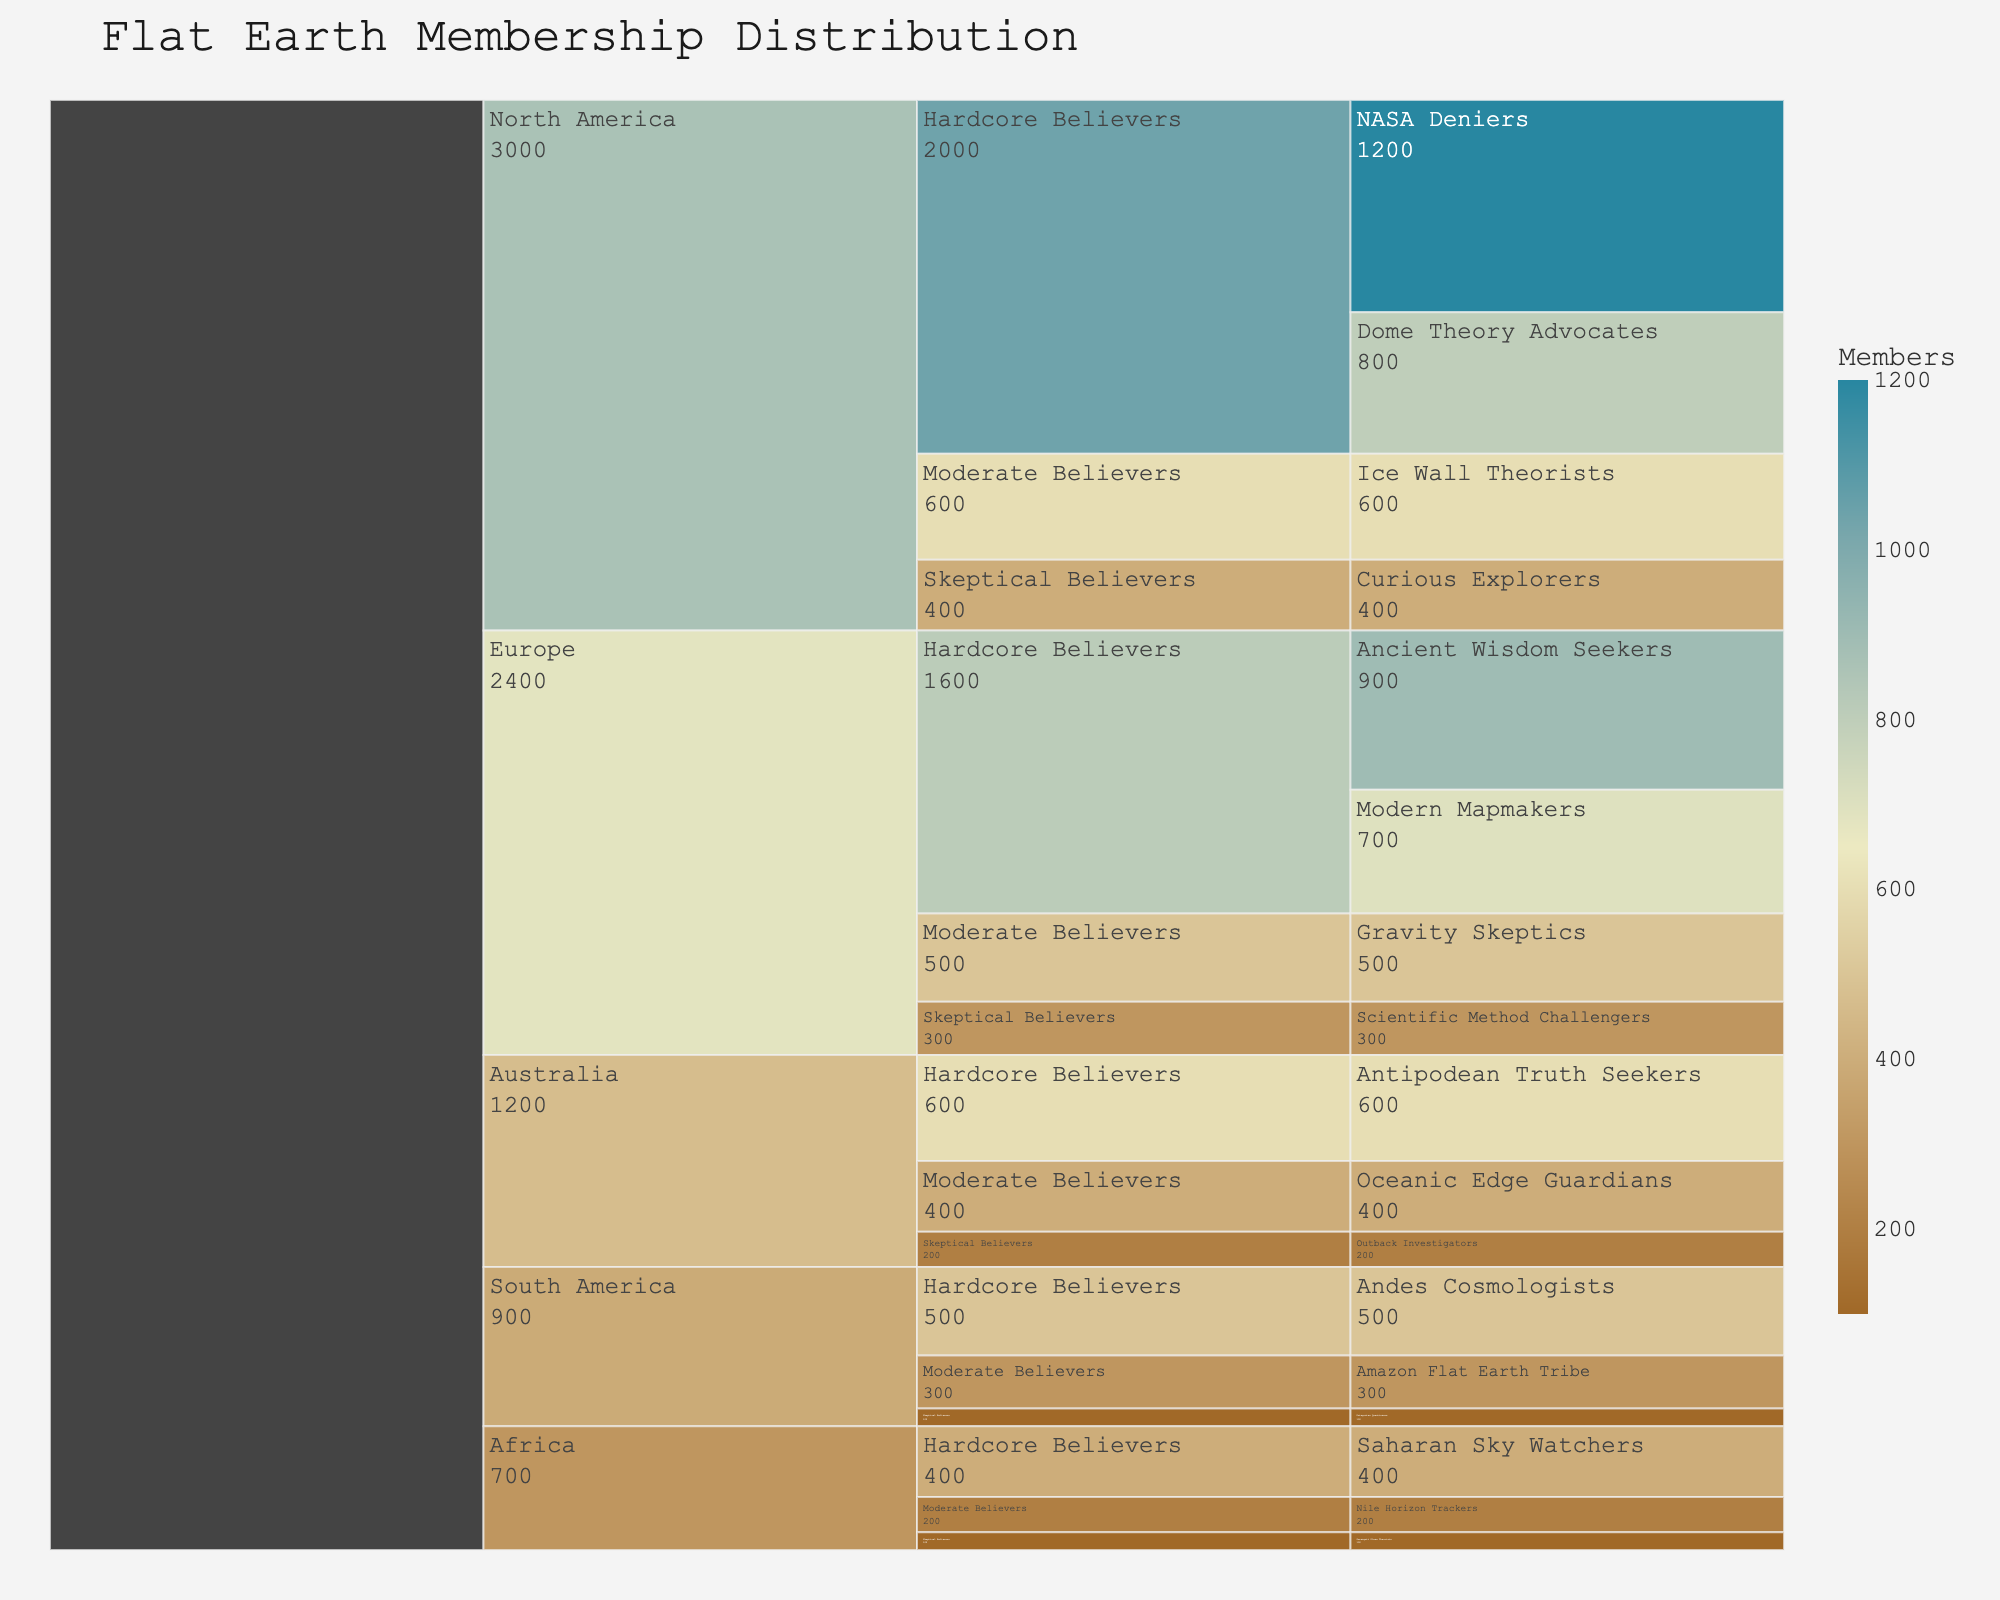What is the title of the figure? The title is usually displayed prominently at the top of the figure. By looking at this part of the figure, we can find the title.
Answer: Flat Earth Membership Distribution Which subgroup in South America has the highest number of members? Look at the South America section in the figure and identify the subgroup with the longest bar or highest value.
Answer: Andes Cosmologists How many total members are there in Australia? Sum the number of members in all subgroups within the Australia section: 600 (Antipodean Truth Seekers) + 400 (Oceanic Edge Guardians) + 200 (Outback Investigators).
Answer: 1200 Which region has the most Hardcore Believers? Compare the number of Hardcore Believers from each region by looking at the figures under the Hardcore Believers category. North America: 1200+800, Europe: 900+700, Australia: 600, South America: 500, Africa: 400. North America has the most.
Answer: North America How many members are categorized as Skeptical Believers in Europe? Sum the members in the Skeptical Believers subgroup within Europe: 300.
Answer: 300 What's the difference in the number of members between the Ice Wall Theorists (North America) and the Patagonian Questioners (South America)? Subtract the number of members of Patagonian Questioners from the Ice Wall Theorists: 600 (Ice Wall Theorists) - 100 (Patagonian Questioners).
Answer: 500 Which region has the smallest number of members in the Skeptical Believers category? Compare the number of Skeptical Believers in each region and find the smallest: North America (400), Europe (300), Australia (200), South America (100), Africa (100). Africa and South America have the same smallest number.
Answer: Africa, South America What is the total number of Hardcore Believers across all regions? Sum the number of Hardcore Believers from all regions: North America: 1200+800, Europe: 900+700, Australia: 600, South America: 500, Africa: 400. The total is (1200+800+900+700+600+500+400).
Answer: 5100 How does the number of Modern Mapmakers in Europe compare to Gravity Skeptics in Europe? Compare the two values in the Europe section. Modern Mapmakers: 700, Gravity Skeptics: 500.
Answer: Modern Mapmakers have more members than Gravity Skeptics Which region has the highest total membership count? Sum the number of members for each region and compare. North America: 1200+800+600+400, Europe: 900+700+500+300, Australia: 600+400+200, South America: 500+300+100, Africa: 400+200+100. Find the highest sum.
Answer: North America 